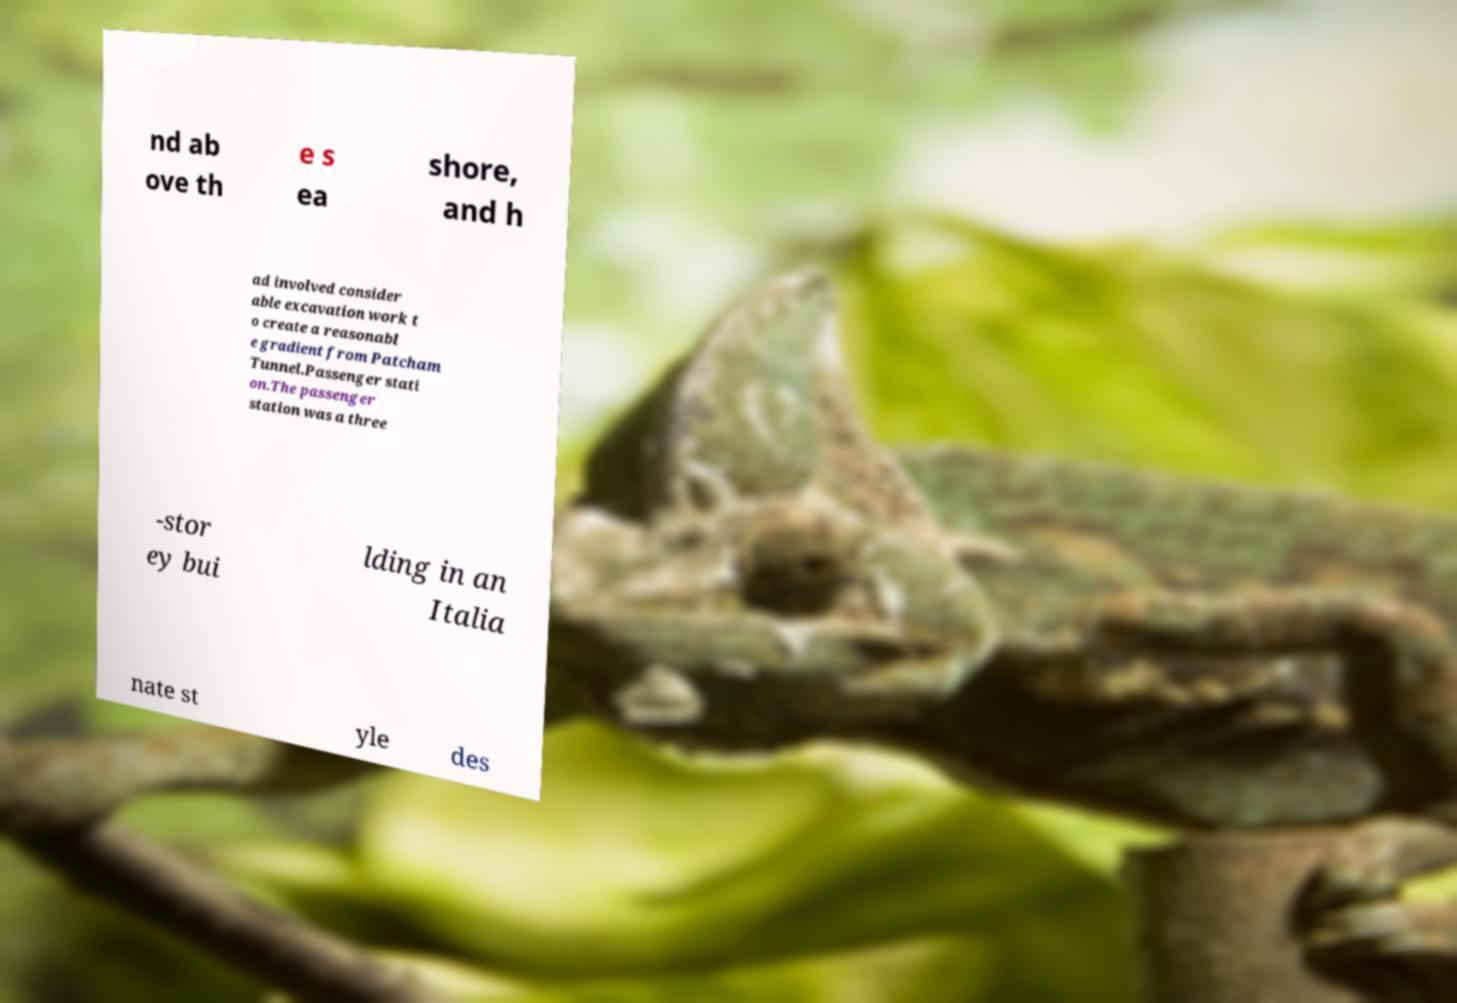Please identify and transcribe the text found in this image. nd ab ove th e s ea shore, and h ad involved consider able excavation work t o create a reasonabl e gradient from Patcham Tunnel.Passenger stati on.The passenger station was a three -stor ey bui lding in an Italia nate st yle des 